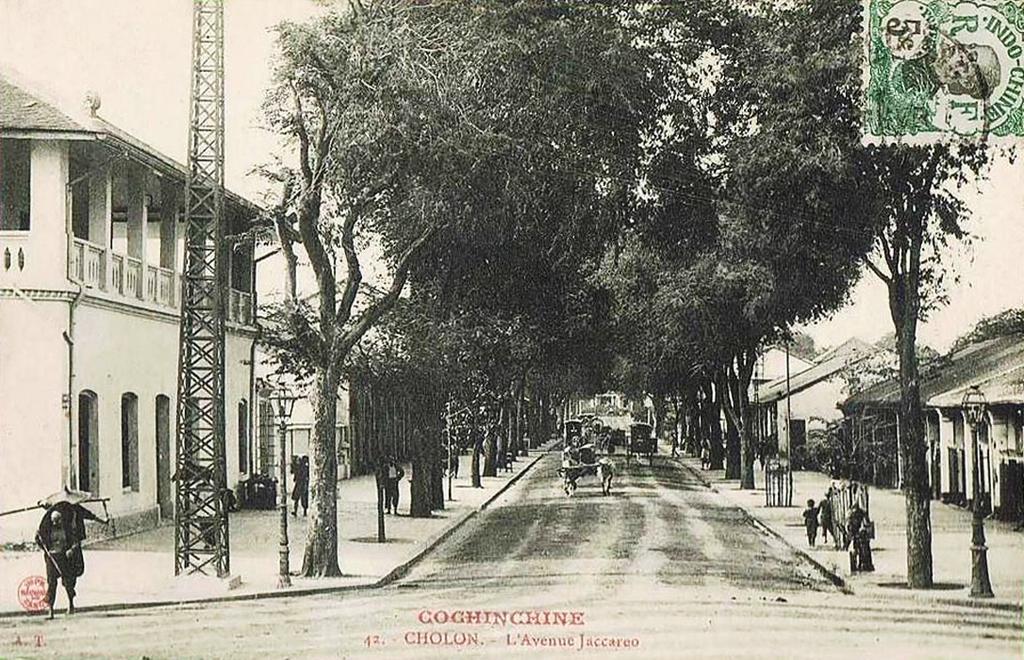How would you summarize this image in a sentence or two? This is the black and white image, where there is a road on which some horse carts are moving and on the other side there are trees, poles and buildings. On the left, there is a tower and there are few persons walking on the side path. On the top, there is the sky and a stamp on the top right corner. 